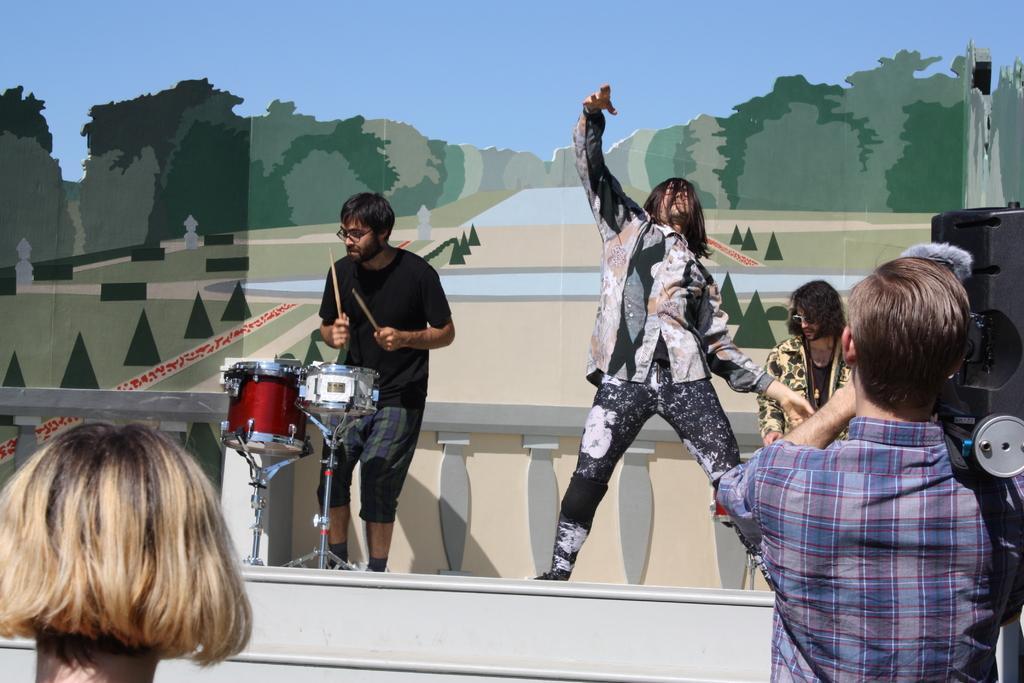Describe this image in one or two sentences. In this image we can see there is a person standing on the stage, beside this person there is another person playing musical instruments and on the right side there is another person. In front of them there are two persons, one of them is holding some object on his shoulder. 